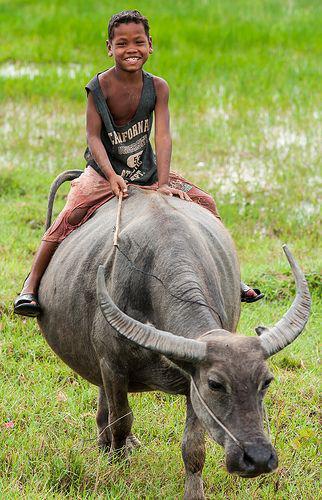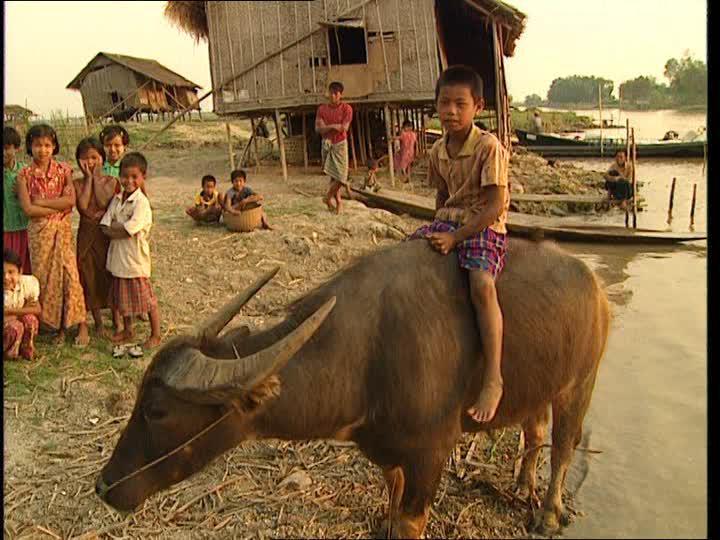The first image is the image on the left, the second image is the image on the right. For the images shown, is this caption "At least two people are riding together on the back of one horned animal in a scene." true? Answer yes or no. No. 